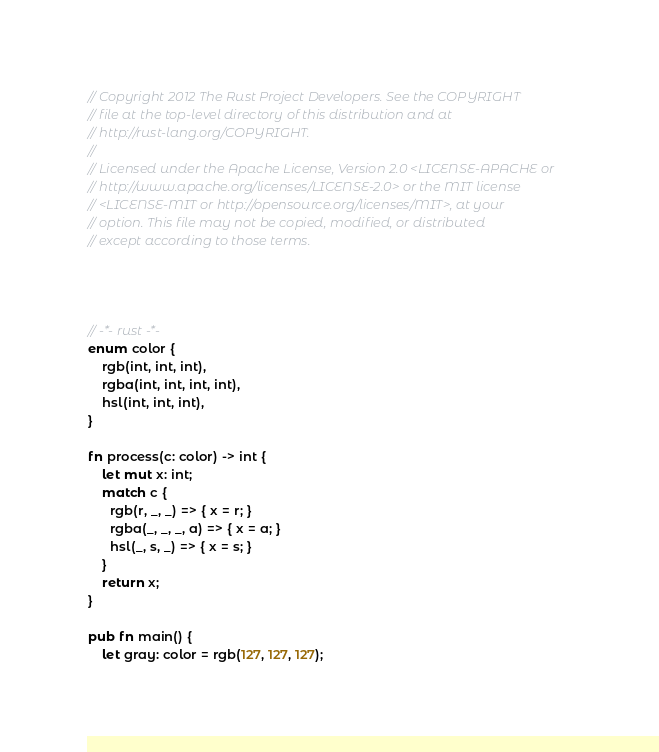<code> <loc_0><loc_0><loc_500><loc_500><_Rust_>// Copyright 2012 The Rust Project Developers. See the COPYRIGHT
// file at the top-level directory of this distribution and at
// http://rust-lang.org/COPYRIGHT.
//
// Licensed under the Apache License, Version 2.0 <LICENSE-APACHE or
// http://www.apache.org/licenses/LICENSE-2.0> or the MIT license
// <LICENSE-MIT or http://opensource.org/licenses/MIT>, at your
// option. This file may not be copied, modified, or distributed
// except according to those terms.




// -*- rust -*-
enum color {
    rgb(int, int, int),
    rgba(int, int, int, int),
    hsl(int, int, int),
}

fn process(c: color) -> int {
    let mut x: int;
    match c {
      rgb(r, _, _) => { x = r; }
      rgba(_, _, _, a) => { x = a; }
      hsl(_, s, _) => { x = s; }
    }
    return x;
}

pub fn main() {
    let gray: color = rgb(127, 127, 127);</code> 